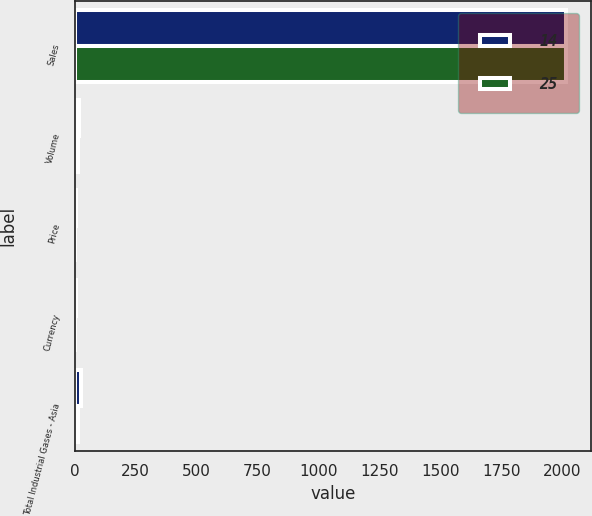Convert chart to OTSL. <chart><loc_0><loc_0><loc_500><loc_500><stacked_bar_chart><ecel><fcel>Sales<fcel>Volume<fcel>Price<fcel>Currency<fcel>Total Industrial Gases - Asia<nl><fcel>14<fcel>2018<fcel>17<fcel>4<fcel>4<fcel>25<nl><fcel>25<fcel>2017<fcel>14<fcel>1<fcel>1<fcel>14<nl></chart> 